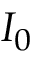<formula> <loc_0><loc_0><loc_500><loc_500>I _ { 0 }</formula> 